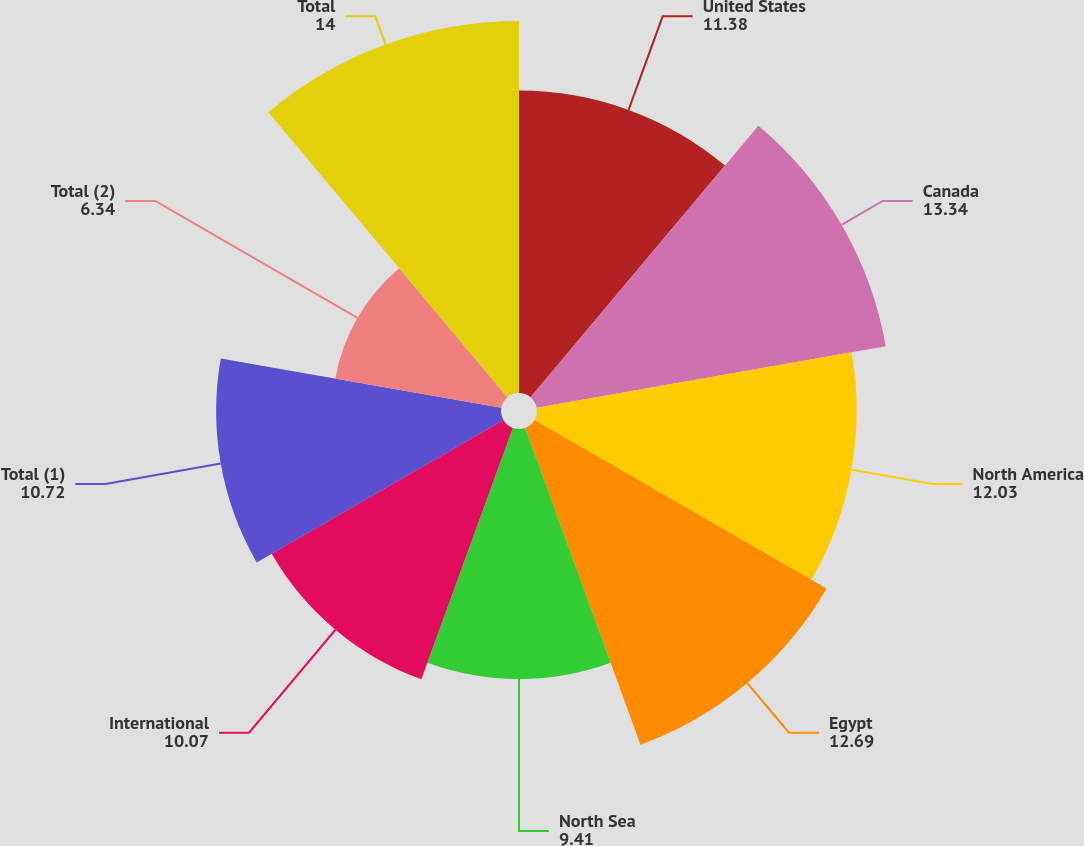Convert chart. <chart><loc_0><loc_0><loc_500><loc_500><pie_chart><fcel>United States<fcel>Canada<fcel>North America<fcel>Egypt<fcel>North Sea<fcel>International<fcel>Total (1)<fcel>Total (2)<fcel>Total<nl><fcel>11.38%<fcel>13.34%<fcel>12.03%<fcel>12.69%<fcel>9.41%<fcel>10.07%<fcel>10.72%<fcel>6.34%<fcel>14.0%<nl></chart> 